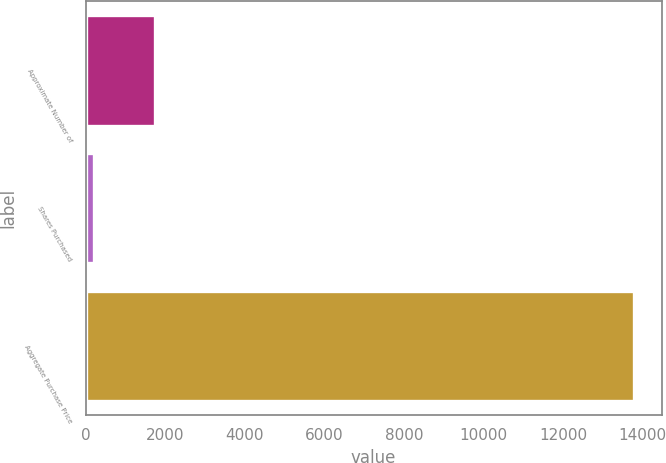Convert chart to OTSL. <chart><loc_0><loc_0><loc_500><loc_500><bar_chart><fcel>Approximate Number of<fcel>Shares Purchased<fcel>Aggregate Purchase Price<nl><fcel>1746<fcel>212<fcel>13787<nl></chart> 